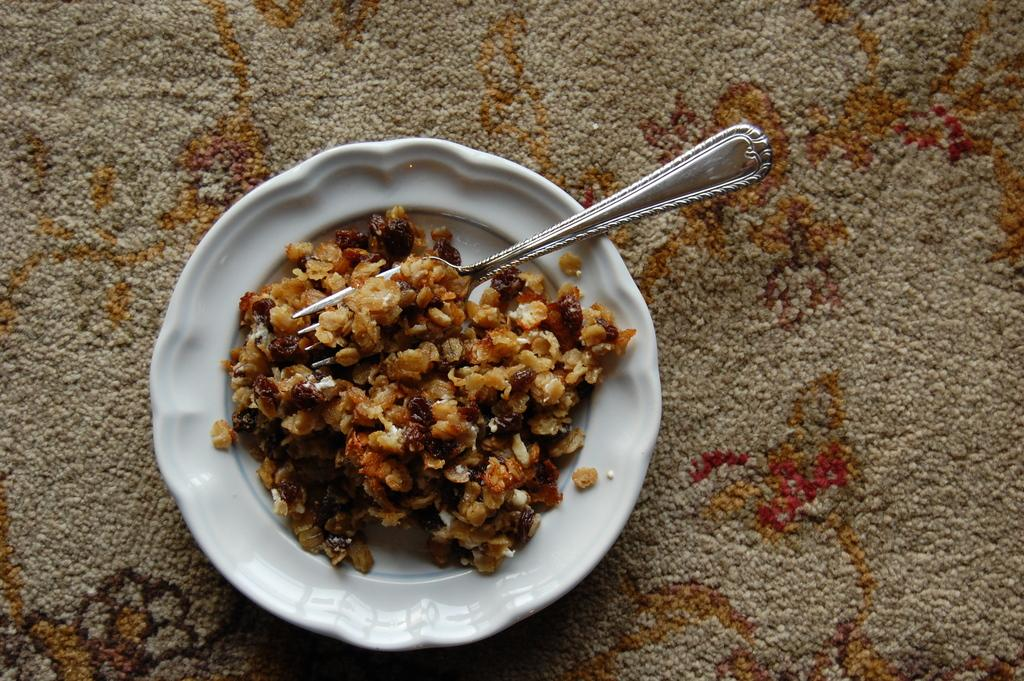What is present in the image that people typically eat? There is food in the image. What utensil can be seen in the image? There is a fork on the plate in the image. What type of material is at the bottom of the image? There is a cloth at the bottom of the image. What type of rice is being stored in the lock in the image? There is no lock or rice present in the image. 